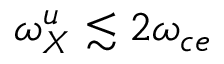Convert formula to latex. <formula><loc_0><loc_0><loc_500><loc_500>\omega _ { X } ^ { u } \lesssim 2 \omega _ { c e }</formula> 